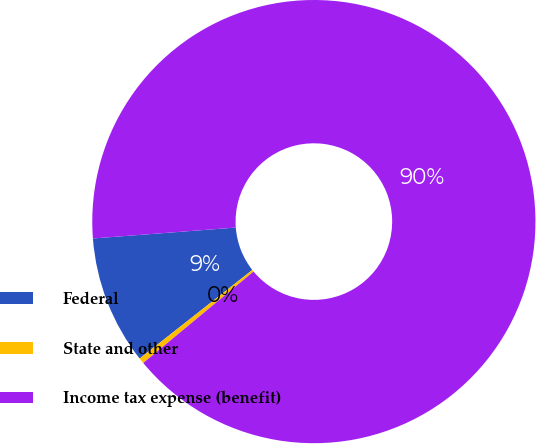<chart> <loc_0><loc_0><loc_500><loc_500><pie_chart><fcel>Federal<fcel>State and other<fcel>Income tax expense (benefit)<nl><fcel>9.39%<fcel>0.41%<fcel>90.2%<nl></chart> 